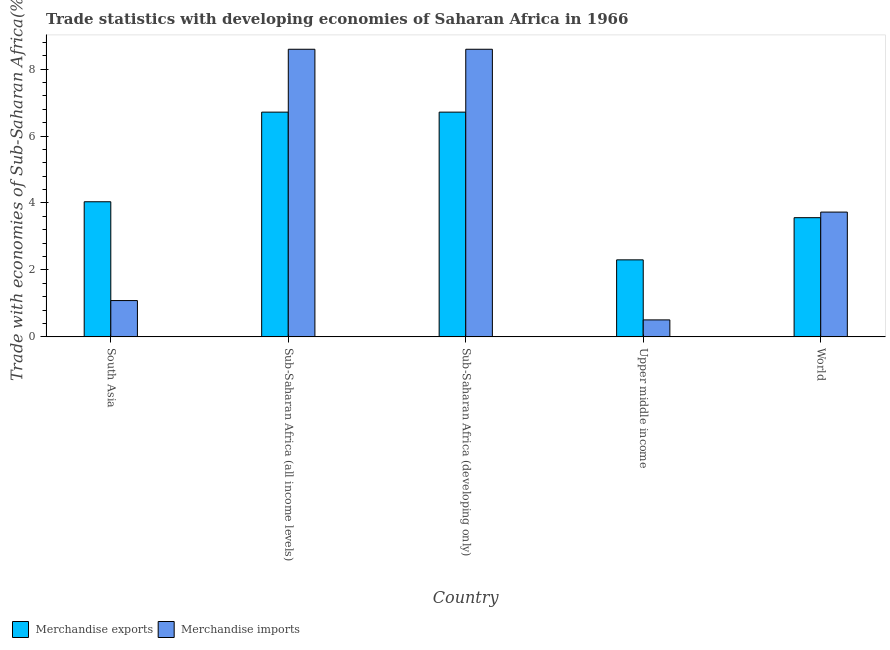How many different coloured bars are there?
Provide a succinct answer. 2. How many groups of bars are there?
Give a very brief answer. 5. Are the number of bars per tick equal to the number of legend labels?
Give a very brief answer. Yes. Are the number of bars on each tick of the X-axis equal?
Your answer should be very brief. Yes. How many bars are there on the 1st tick from the right?
Provide a short and direct response. 2. What is the label of the 2nd group of bars from the left?
Offer a terse response. Sub-Saharan Africa (all income levels). In how many cases, is the number of bars for a given country not equal to the number of legend labels?
Offer a very short reply. 0. What is the merchandise exports in World?
Your answer should be compact. 3.56. Across all countries, what is the maximum merchandise exports?
Offer a terse response. 6.71. Across all countries, what is the minimum merchandise imports?
Your answer should be compact. 0.51. In which country was the merchandise imports maximum?
Keep it short and to the point. Sub-Saharan Africa (all income levels). In which country was the merchandise imports minimum?
Provide a short and direct response. Upper middle income. What is the total merchandise exports in the graph?
Make the answer very short. 23.33. What is the difference between the merchandise imports in Sub-Saharan Africa (developing only) and that in Upper middle income?
Provide a short and direct response. 8.09. What is the difference between the merchandise imports in Sub-Saharan Africa (developing only) and the merchandise exports in World?
Offer a very short reply. 5.03. What is the average merchandise imports per country?
Ensure brevity in your answer.  4.5. What is the difference between the merchandise exports and merchandise imports in Sub-Saharan Africa (all income levels)?
Your answer should be compact. -1.88. What is the ratio of the merchandise imports in South Asia to that in Sub-Saharan Africa (all income levels)?
Offer a very short reply. 0.13. Is the difference between the merchandise exports in Sub-Saharan Africa (all income levels) and World greater than the difference between the merchandise imports in Sub-Saharan Africa (all income levels) and World?
Your answer should be compact. No. What is the difference between the highest and the second highest merchandise exports?
Provide a succinct answer. 0. What is the difference between the highest and the lowest merchandise exports?
Keep it short and to the point. 4.41. In how many countries, is the merchandise exports greater than the average merchandise exports taken over all countries?
Give a very brief answer. 2. What does the 1st bar from the left in South Asia represents?
Ensure brevity in your answer.  Merchandise exports. What does the 2nd bar from the right in Upper middle income represents?
Your response must be concise. Merchandise exports. How many bars are there?
Offer a very short reply. 10. Does the graph contain any zero values?
Your answer should be very brief. No. Does the graph contain grids?
Keep it short and to the point. No. Where does the legend appear in the graph?
Ensure brevity in your answer.  Bottom left. How are the legend labels stacked?
Offer a very short reply. Horizontal. What is the title of the graph?
Give a very brief answer. Trade statistics with developing economies of Saharan Africa in 1966. What is the label or title of the Y-axis?
Make the answer very short. Trade with economies of Sub-Saharan Africa(%). What is the Trade with economies of Sub-Saharan Africa(%) of Merchandise exports in South Asia?
Keep it short and to the point. 4.04. What is the Trade with economies of Sub-Saharan Africa(%) in Merchandise imports in South Asia?
Provide a succinct answer. 1.08. What is the Trade with economies of Sub-Saharan Africa(%) in Merchandise exports in Sub-Saharan Africa (all income levels)?
Offer a terse response. 6.71. What is the Trade with economies of Sub-Saharan Africa(%) of Merchandise imports in Sub-Saharan Africa (all income levels)?
Keep it short and to the point. 8.59. What is the Trade with economies of Sub-Saharan Africa(%) in Merchandise exports in Sub-Saharan Africa (developing only)?
Make the answer very short. 6.71. What is the Trade with economies of Sub-Saharan Africa(%) of Merchandise imports in Sub-Saharan Africa (developing only)?
Give a very brief answer. 8.59. What is the Trade with economies of Sub-Saharan Africa(%) in Merchandise exports in Upper middle income?
Offer a very short reply. 2.3. What is the Trade with economies of Sub-Saharan Africa(%) in Merchandise imports in Upper middle income?
Your answer should be very brief. 0.51. What is the Trade with economies of Sub-Saharan Africa(%) in Merchandise exports in World?
Your answer should be compact. 3.56. What is the Trade with economies of Sub-Saharan Africa(%) in Merchandise imports in World?
Give a very brief answer. 3.73. Across all countries, what is the maximum Trade with economies of Sub-Saharan Africa(%) of Merchandise exports?
Offer a very short reply. 6.71. Across all countries, what is the maximum Trade with economies of Sub-Saharan Africa(%) in Merchandise imports?
Offer a very short reply. 8.59. Across all countries, what is the minimum Trade with economies of Sub-Saharan Africa(%) of Merchandise exports?
Your response must be concise. 2.3. Across all countries, what is the minimum Trade with economies of Sub-Saharan Africa(%) in Merchandise imports?
Ensure brevity in your answer.  0.51. What is the total Trade with economies of Sub-Saharan Africa(%) in Merchandise exports in the graph?
Offer a very short reply. 23.33. What is the total Trade with economies of Sub-Saharan Africa(%) in Merchandise imports in the graph?
Make the answer very short. 22.5. What is the difference between the Trade with economies of Sub-Saharan Africa(%) in Merchandise exports in South Asia and that in Sub-Saharan Africa (all income levels)?
Offer a terse response. -2.68. What is the difference between the Trade with economies of Sub-Saharan Africa(%) of Merchandise imports in South Asia and that in Sub-Saharan Africa (all income levels)?
Your answer should be very brief. -7.51. What is the difference between the Trade with economies of Sub-Saharan Africa(%) in Merchandise exports in South Asia and that in Sub-Saharan Africa (developing only)?
Ensure brevity in your answer.  -2.68. What is the difference between the Trade with economies of Sub-Saharan Africa(%) of Merchandise imports in South Asia and that in Sub-Saharan Africa (developing only)?
Give a very brief answer. -7.51. What is the difference between the Trade with economies of Sub-Saharan Africa(%) in Merchandise exports in South Asia and that in Upper middle income?
Your answer should be compact. 1.74. What is the difference between the Trade with economies of Sub-Saharan Africa(%) of Merchandise imports in South Asia and that in Upper middle income?
Your answer should be very brief. 0.58. What is the difference between the Trade with economies of Sub-Saharan Africa(%) of Merchandise exports in South Asia and that in World?
Keep it short and to the point. 0.48. What is the difference between the Trade with economies of Sub-Saharan Africa(%) of Merchandise imports in South Asia and that in World?
Your response must be concise. -2.64. What is the difference between the Trade with economies of Sub-Saharan Africa(%) in Merchandise exports in Sub-Saharan Africa (all income levels) and that in Sub-Saharan Africa (developing only)?
Make the answer very short. 0. What is the difference between the Trade with economies of Sub-Saharan Africa(%) of Merchandise exports in Sub-Saharan Africa (all income levels) and that in Upper middle income?
Keep it short and to the point. 4.41. What is the difference between the Trade with economies of Sub-Saharan Africa(%) in Merchandise imports in Sub-Saharan Africa (all income levels) and that in Upper middle income?
Provide a succinct answer. 8.09. What is the difference between the Trade with economies of Sub-Saharan Africa(%) of Merchandise exports in Sub-Saharan Africa (all income levels) and that in World?
Give a very brief answer. 3.15. What is the difference between the Trade with economies of Sub-Saharan Africa(%) in Merchandise imports in Sub-Saharan Africa (all income levels) and that in World?
Offer a very short reply. 4.86. What is the difference between the Trade with economies of Sub-Saharan Africa(%) of Merchandise exports in Sub-Saharan Africa (developing only) and that in Upper middle income?
Provide a short and direct response. 4.41. What is the difference between the Trade with economies of Sub-Saharan Africa(%) of Merchandise imports in Sub-Saharan Africa (developing only) and that in Upper middle income?
Your answer should be compact. 8.09. What is the difference between the Trade with economies of Sub-Saharan Africa(%) in Merchandise exports in Sub-Saharan Africa (developing only) and that in World?
Your answer should be very brief. 3.15. What is the difference between the Trade with economies of Sub-Saharan Africa(%) of Merchandise imports in Sub-Saharan Africa (developing only) and that in World?
Your answer should be very brief. 4.86. What is the difference between the Trade with economies of Sub-Saharan Africa(%) of Merchandise exports in Upper middle income and that in World?
Your response must be concise. -1.26. What is the difference between the Trade with economies of Sub-Saharan Africa(%) in Merchandise imports in Upper middle income and that in World?
Your response must be concise. -3.22. What is the difference between the Trade with economies of Sub-Saharan Africa(%) in Merchandise exports in South Asia and the Trade with economies of Sub-Saharan Africa(%) in Merchandise imports in Sub-Saharan Africa (all income levels)?
Ensure brevity in your answer.  -4.56. What is the difference between the Trade with economies of Sub-Saharan Africa(%) in Merchandise exports in South Asia and the Trade with economies of Sub-Saharan Africa(%) in Merchandise imports in Sub-Saharan Africa (developing only)?
Provide a short and direct response. -4.56. What is the difference between the Trade with economies of Sub-Saharan Africa(%) in Merchandise exports in South Asia and the Trade with economies of Sub-Saharan Africa(%) in Merchandise imports in Upper middle income?
Your answer should be compact. 3.53. What is the difference between the Trade with economies of Sub-Saharan Africa(%) in Merchandise exports in South Asia and the Trade with economies of Sub-Saharan Africa(%) in Merchandise imports in World?
Your answer should be very brief. 0.31. What is the difference between the Trade with economies of Sub-Saharan Africa(%) in Merchandise exports in Sub-Saharan Africa (all income levels) and the Trade with economies of Sub-Saharan Africa(%) in Merchandise imports in Sub-Saharan Africa (developing only)?
Offer a very short reply. -1.88. What is the difference between the Trade with economies of Sub-Saharan Africa(%) of Merchandise exports in Sub-Saharan Africa (all income levels) and the Trade with economies of Sub-Saharan Africa(%) of Merchandise imports in Upper middle income?
Provide a succinct answer. 6.21. What is the difference between the Trade with economies of Sub-Saharan Africa(%) in Merchandise exports in Sub-Saharan Africa (all income levels) and the Trade with economies of Sub-Saharan Africa(%) in Merchandise imports in World?
Ensure brevity in your answer.  2.99. What is the difference between the Trade with economies of Sub-Saharan Africa(%) in Merchandise exports in Sub-Saharan Africa (developing only) and the Trade with economies of Sub-Saharan Africa(%) in Merchandise imports in Upper middle income?
Give a very brief answer. 6.21. What is the difference between the Trade with economies of Sub-Saharan Africa(%) of Merchandise exports in Sub-Saharan Africa (developing only) and the Trade with economies of Sub-Saharan Africa(%) of Merchandise imports in World?
Keep it short and to the point. 2.99. What is the difference between the Trade with economies of Sub-Saharan Africa(%) in Merchandise exports in Upper middle income and the Trade with economies of Sub-Saharan Africa(%) in Merchandise imports in World?
Make the answer very short. -1.43. What is the average Trade with economies of Sub-Saharan Africa(%) of Merchandise exports per country?
Your answer should be compact. 4.67. What is the average Trade with economies of Sub-Saharan Africa(%) in Merchandise imports per country?
Ensure brevity in your answer.  4.5. What is the difference between the Trade with economies of Sub-Saharan Africa(%) of Merchandise exports and Trade with economies of Sub-Saharan Africa(%) of Merchandise imports in South Asia?
Keep it short and to the point. 2.95. What is the difference between the Trade with economies of Sub-Saharan Africa(%) of Merchandise exports and Trade with economies of Sub-Saharan Africa(%) of Merchandise imports in Sub-Saharan Africa (all income levels)?
Offer a very short reply. -1.88. What is the difference between the Trade with economies of Sub-Saharan Africa(%) of Merchandise exports and Trade with economies of Sub-Saharan Africa(%) of Merchandise imports in Sub-Saharan Africa (developing only)?
Give a very brief answer. -1.88. What is the difference between the Trade with economies of Sub-Saharan Africa(%) in Merchandise exports and Trade with economies of Sub-Saharan Africa(%) in Merchandise imports in Upper middle income?
Offer a terse response. 1.79. What is the difference between the Trade with economies of Sub-Saharan Africa(%) in Merchandise exports and Trade with economies of Sub-Saharan Africa(%) in Merchandise imports in World?
Keep it short and to the point. -0.17. What is the ratio of the Trade with economies of Sub-Saharan Africa(%) of Merchandise exports in South Asia to that in Sub-Saharan Africa (all income levels)?
Your response must be concise. 0.6. What is the ratio of the Trade with economies of Sub-Saharan Africa(%) in Merchandise imports in South Asia to that in Sub-Saharan Africa (all income levels)?
Offer a terse response. 0.13. What is the ratio of the Trade with economies of Sub-Saharan Africa(%) of Merchandise exports in South Asia to that in Sub-Saharan Africa (developing only)?
Provide a short and direct response. 0.6. What is the ratio of the Trade with economies of Sub-Saharan Africa(%) of Merchandise imports in South Asia to that in Sub-Saharan Africa (developing only)?
Provide a short and direct response. 0.13. What is the ratio of the Trade with economies of Sub-Saharan Africa(%) of Merchandise exports in South Asia to that in Upper middle income?
Your answer should be compact. 1.75. What is the ratio of the Trade with economies of Sub-Saharan Africa(%) in Merchandise imports in South Asia to that in Upper middle income?
Make the answer very short. 2.14. What is the ratio of the Trade with economies of Sub-Saharan Africa(%) of Merchandise exports in South Asia to that in World?
Keep it short and to the point. 1.13. What is the ratio of the Trade with economies of Sub-Saharan Africa(%) in Merchandise imports in South Asia to that in World?
Your answer should be compact. 0.29. What is the ratio of the Trade with economies of Sub-Saharan Africa(%) of Merchandise exports in Sub-Saharan Africa (all income levels) to that in Sub-Saharan Africa (developing only)?
Offer a very short reply. 1. What is the ratio of the Trade with economies of Sub-Saharan Africa(%) of Merchandise imports in Sub-Saharan Africa (all income levels) to that in Sub-Saharan Africa (developing only)?
Keep it short and to the point. 1. What is the ratio of the Trade with economies of Sub-Saharan Africa(%) of Merchandise exports in Sub-Saharan Africa (all income levels) to that in Upper middle income?
Give a very brief answer. 2.92. What is the ratio of the Trade with economies of Sub-Saharan Africa(%) of Merchandise imports in Sub-Saharan Africa (all income levels) to that in Upper middle income?
Provide a short and direct response. 16.95. What is the ratio of the Trade with economies of Sub-Saharan Africa(%) of Merchandise exports in Sub-Saharan Africa (all income levels) to that in World?
Make the answer very short. 1.89. What is the ratio of the Trade with economies of Sub-Saharan Africa(%) in Merchandise imports in Sub-Saharan Africa (all income levels) to that in World?
Your response must be concise. 2.3. What is the ratio of the Trade with economies of Sub-Saharan Africa(%) in Merchandise exports in Sub-Saharan Africa (developing only) to that in Upper middle income?
Provide a succinct answer. 2.92. What is the ratio of the Trade with economies of Sub-Saharan Africa(%) in Merchandise imports in Sub-Saharan Africa (developing only) to that in Upper middle income?
Give a very brief answer. 16.95. What is the ratio of the Trade with economies of Sub-Saharan Africa(%) in Merchandise exports in Sub-Saharan Africa (developing only) to that in World?
Your answer should be compact. 1.89. What is the ratio of the Trade with economies of Sub-Saharan Africa(%) of Merchandise imports in Sub-Saharan Africa (developing only) to that in World?
Your answer should be compact. 2.3. What is the ratio of the Trade with economies of Sub-Saharan Africa(%) in Merchandise exports in Upper middle income to that in World?
Ensure brevity in your answer.  0.65. What is the ratio of the Trade with economies of Sub-Saharan Africa(%) of Merchandise imports in Upper middle income to that in World?
Your answer should be compact. 0.14. What is the difference between the highest and the second highest Trade with economies of Sub-Saharan Africa(%) in Merchandise imports?
Provide a short and direct response. 0. What is the difference between the highest and the lowest Trade with economies of Sub-Saharan Africa(%) in Merchandise exports?
Provide a succinct answer. 4.41. What is the difference between the highest and the lowest Trade with economies of Sub-Saharan Africa(%) in Merchandise imports?
Your answer should be compact. 8.09. 